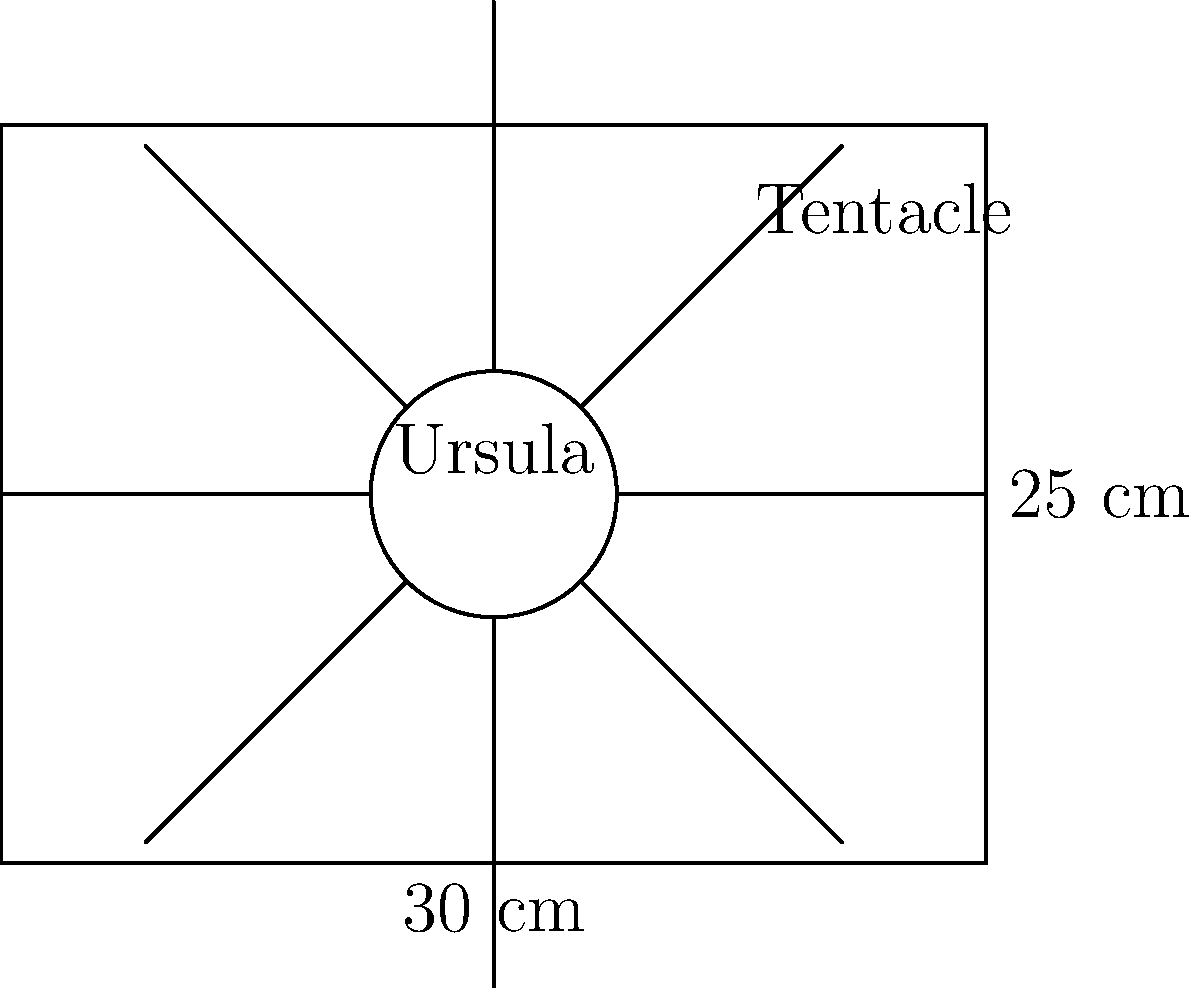Ursula's body measures 30 cm wide and 25 cm tall. Each of her 8 tentacles is approximately 150 cm long and 10 cm wide at the base, tapering to 2 cm at the tip. Assuming a triangular shape for each tentacle, calculate the total fabric yardage required for all tentacles, given that the fabric is 115 cm wide. Round your answer to the nearest 0.1 yards. To calculate the fabric yardage for Ursula's tentacles, we'll follow these steps:

1) Calculate the area of one tentacle:
   Base width = 10 cm, Tip width = 2 cm, Length = 150 cm
   Area of one tentacle = $\frac{1}{2} * (10 + 2) * 150 = 900$ cm²

2) Calculate the total area for all 8 tentacles:
   Total area = $900 * 8 = 7200$ cm²

3) Convert the total area to square meters:
   $7200$ cm² $= 0.72$ m²

4) Calculate the length of fabric needed:
   Fabric width = 115 cm = 1.15 m
   Length needed = $\frac{0.72}{1.15} = 0.6261$ m

5) Convert meters to yards:
   $0.6261$ m $* \frac{1.0936 \text{ yards}}{1 \text{ m}} = 0.6847$ yards

6) Round to the nearest 0.1 yards:
   0.6847 rounds to 0.7 yards

Therefore, approximately 0.7 yards of fabric are required for Ursula's tentacles.
Answer: 0.7 yards 